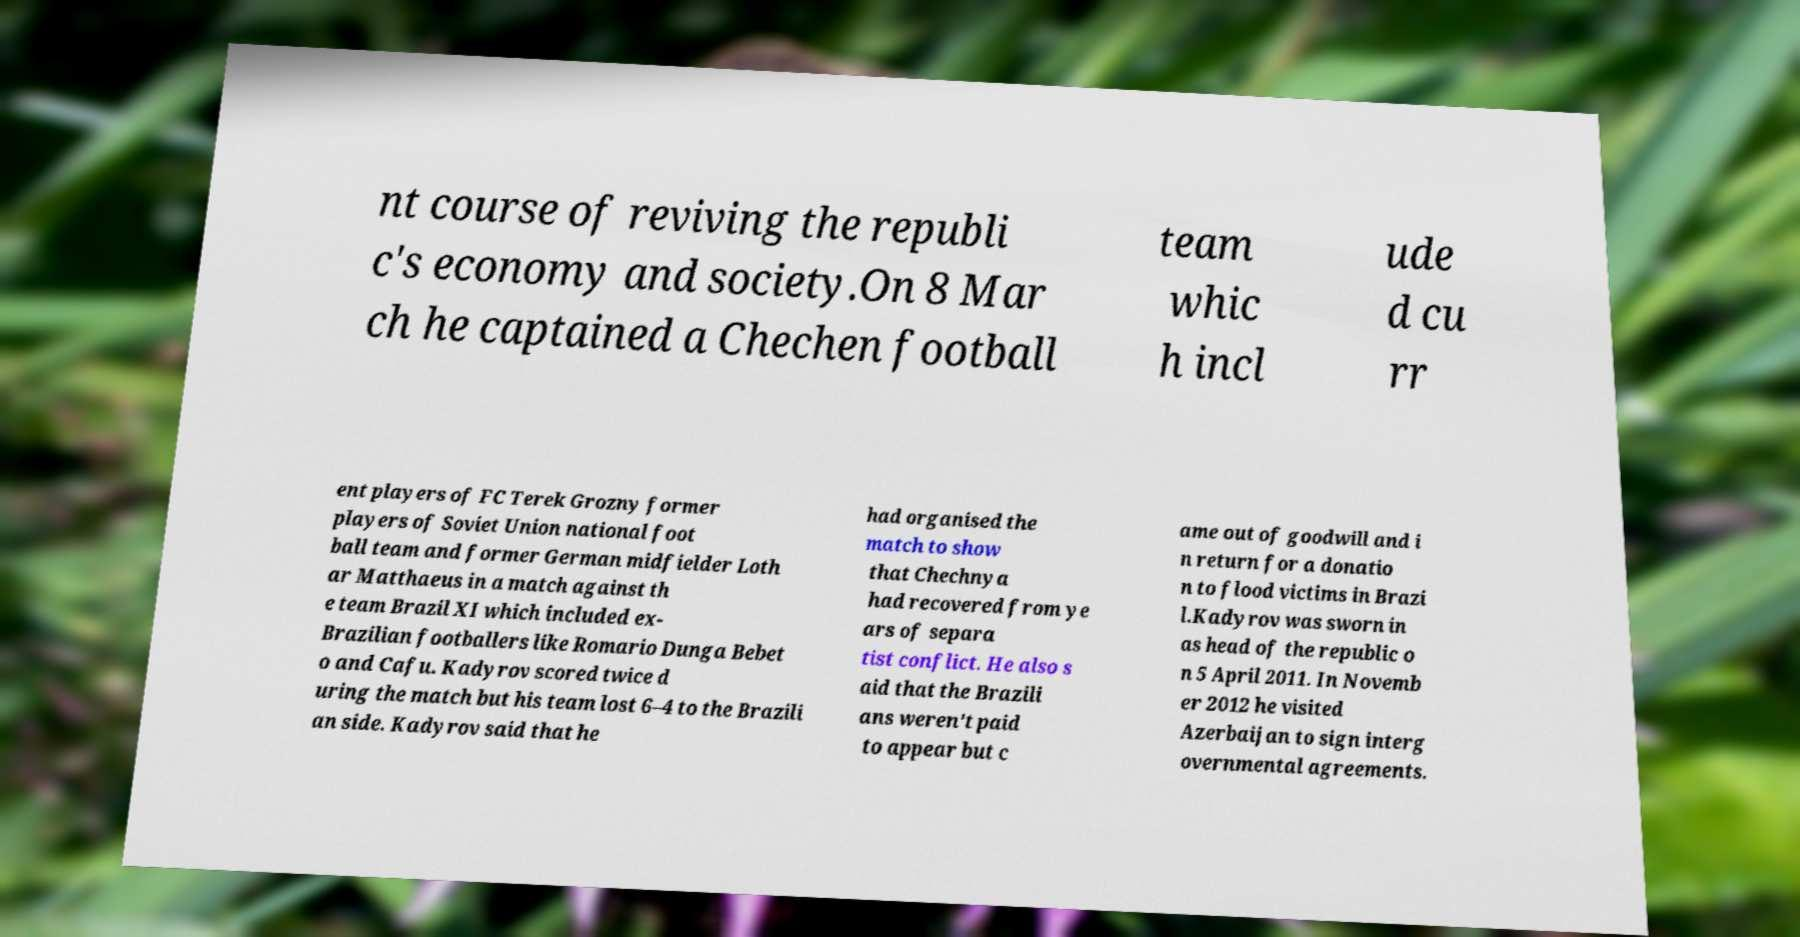There's text embedded in this image that I need extracted. Can you transcribe it verbatim? nt course of reviving the republi c's economy and society.On 8 Mar ch he captained a Chechen football team whic h incl ude d cu rr ent players of FC Terek Grozny former players of Soviet Union national foot ball team and former German midfielder Loth ar Matthaeus in a match against th e team Brazil XI which included ex- Brazilian footballers like Romario Dunga Bebet o and Cafu. Kadyrov scored twice d uring the match but his team lost 6–4 to the Brazili an side. Kadyrov said that he had organised the match to show that Chechnya had recovered from ye ars of separa tist conflict. He also s aid that the Brazili ans weren't paid to appear but c ame out of goodwill and i n return for a donatio n to flood victims in Brazi l.Kadyrov was sworn in as head of the republic o n 5 April 2011. In Novemb er 2012 he visited Azerbaijan to sign interg overnmental agreements. 